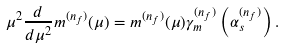<formula> <loc_0><loc_0><loc_500><loc_500>\mu ^ { 2 } \frac { d } { d \mu ^ { 2 } } m ^ { ( n _ { f } ) } ( \mu ) = m ^ { ( n _ { f } ) } ( \mu ) \gamma _ { m } ^ { ( n _ { f } ) } \left ( \alpha _ { s } ^ { ( n _ { f } ) } \right ) .</formula> 